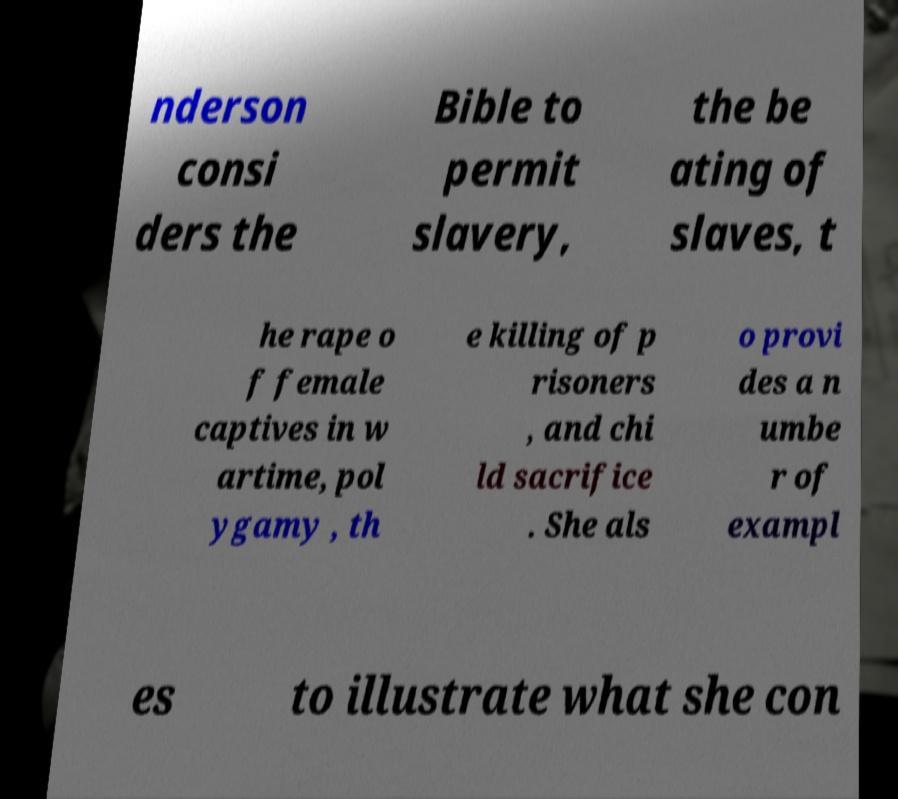What messages or text are displayed in this image? I need them in a readable, typed format. nderson consi ders the Bible to permit slavery, the be ating of slaves, t he rape o f female captives in w artime, pol ygamy , th e killing of p risoners , and chi ld sacrifice . She als o provi des a n umbe r of exampl es to illustrate what she con 